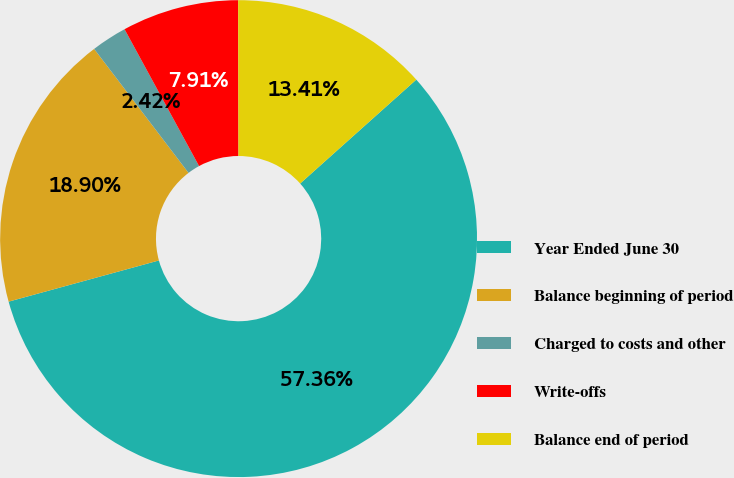Convert chart to OTSL. <chart><loc_0><loc_0><loc_500><loc_500><pie_chart><fcel>Year Ended June 30<fcel>Balance beginning of period<fcel>Charged to costs and other<fcel>Write-offs<fcel>Balance end of period<nl><fcel>57.36%<fcel>18.9%<fcel>2.42%<fcel>7.91%<fcel>13.41%<nl></chart> 